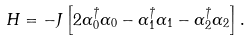Convert formula to latex. <formula><loc_0><loc_0><loc_500><loc_500>H = - J \left [ 2 \alpha _ { 0 } ^ { \dag } \alpha _ { 0 } - \alpha _ { 1 } ^ { \dag } \alpha _ { 1 } - \alpha _ { 2 } ^ { \dag } \alpha _ { 2 } \right ] .</formula> 